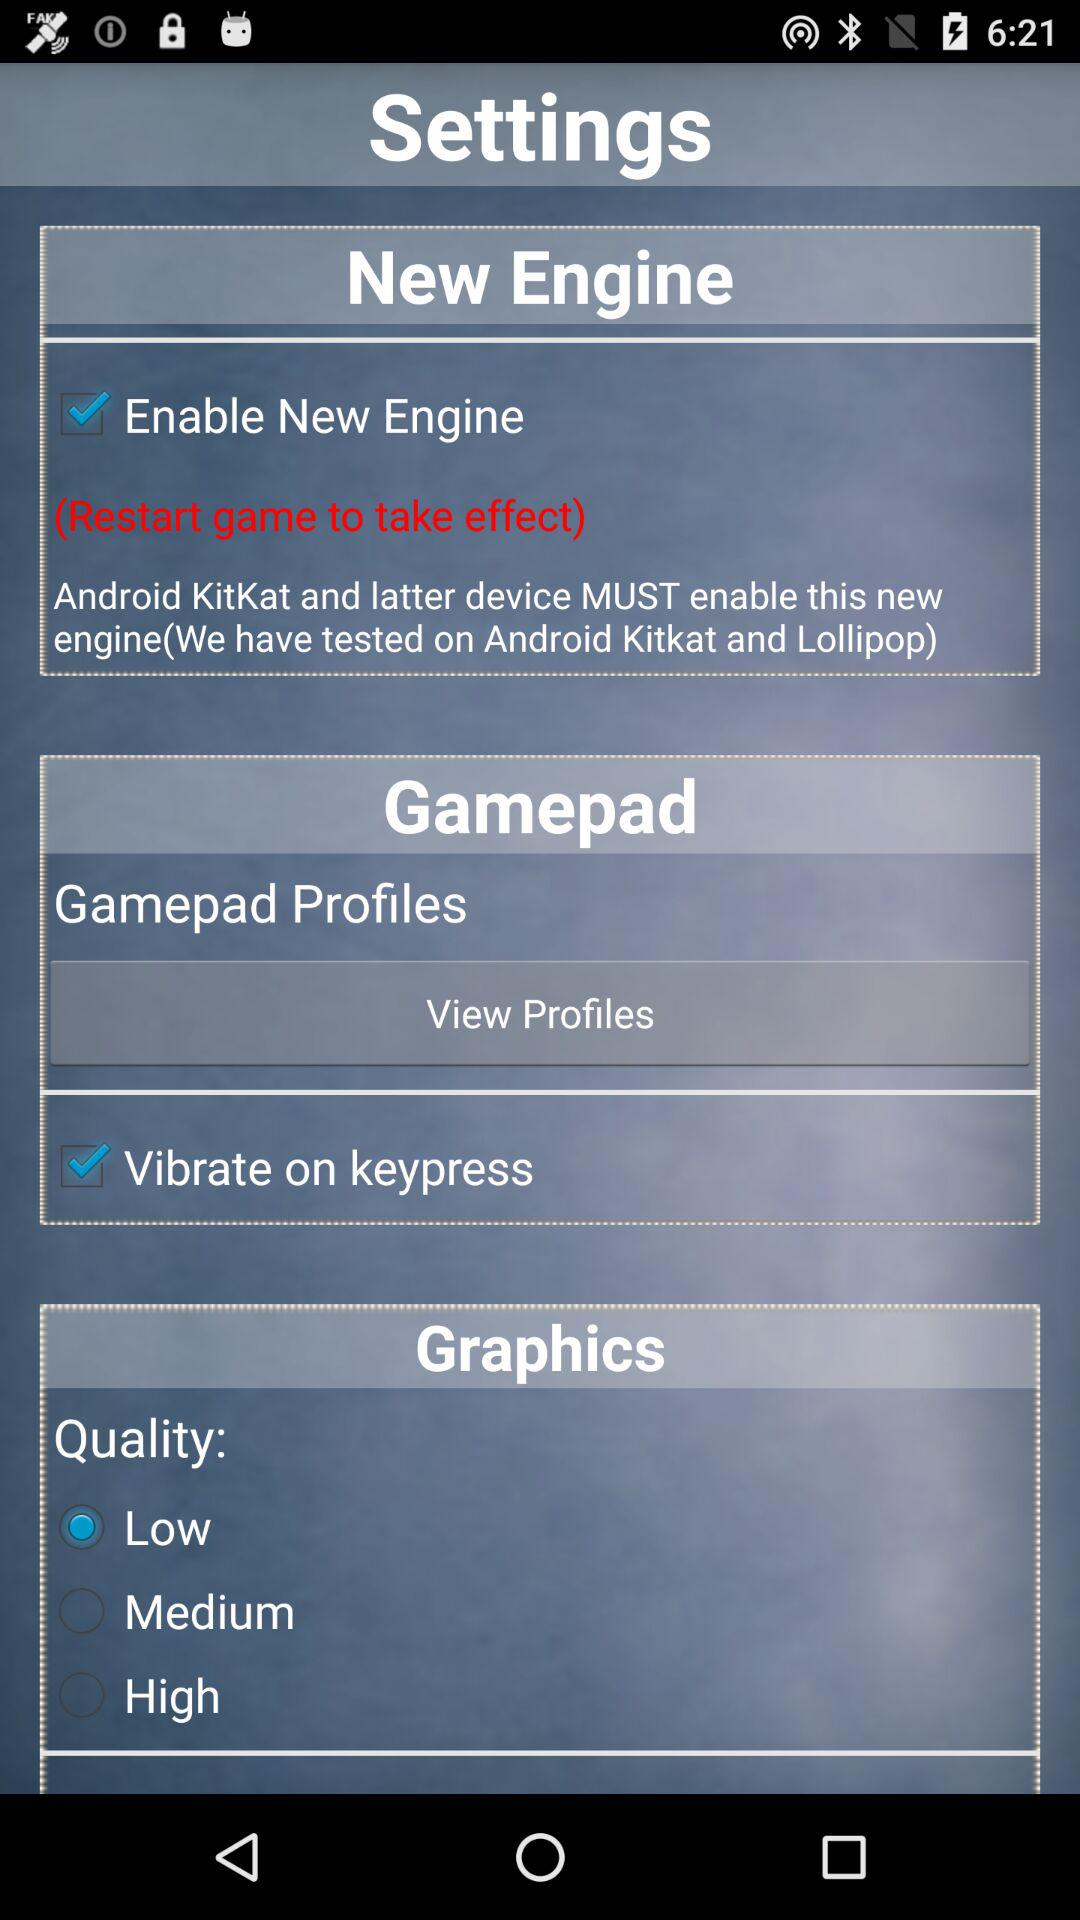What is the status of vibrate on keypress? The status is "on". 